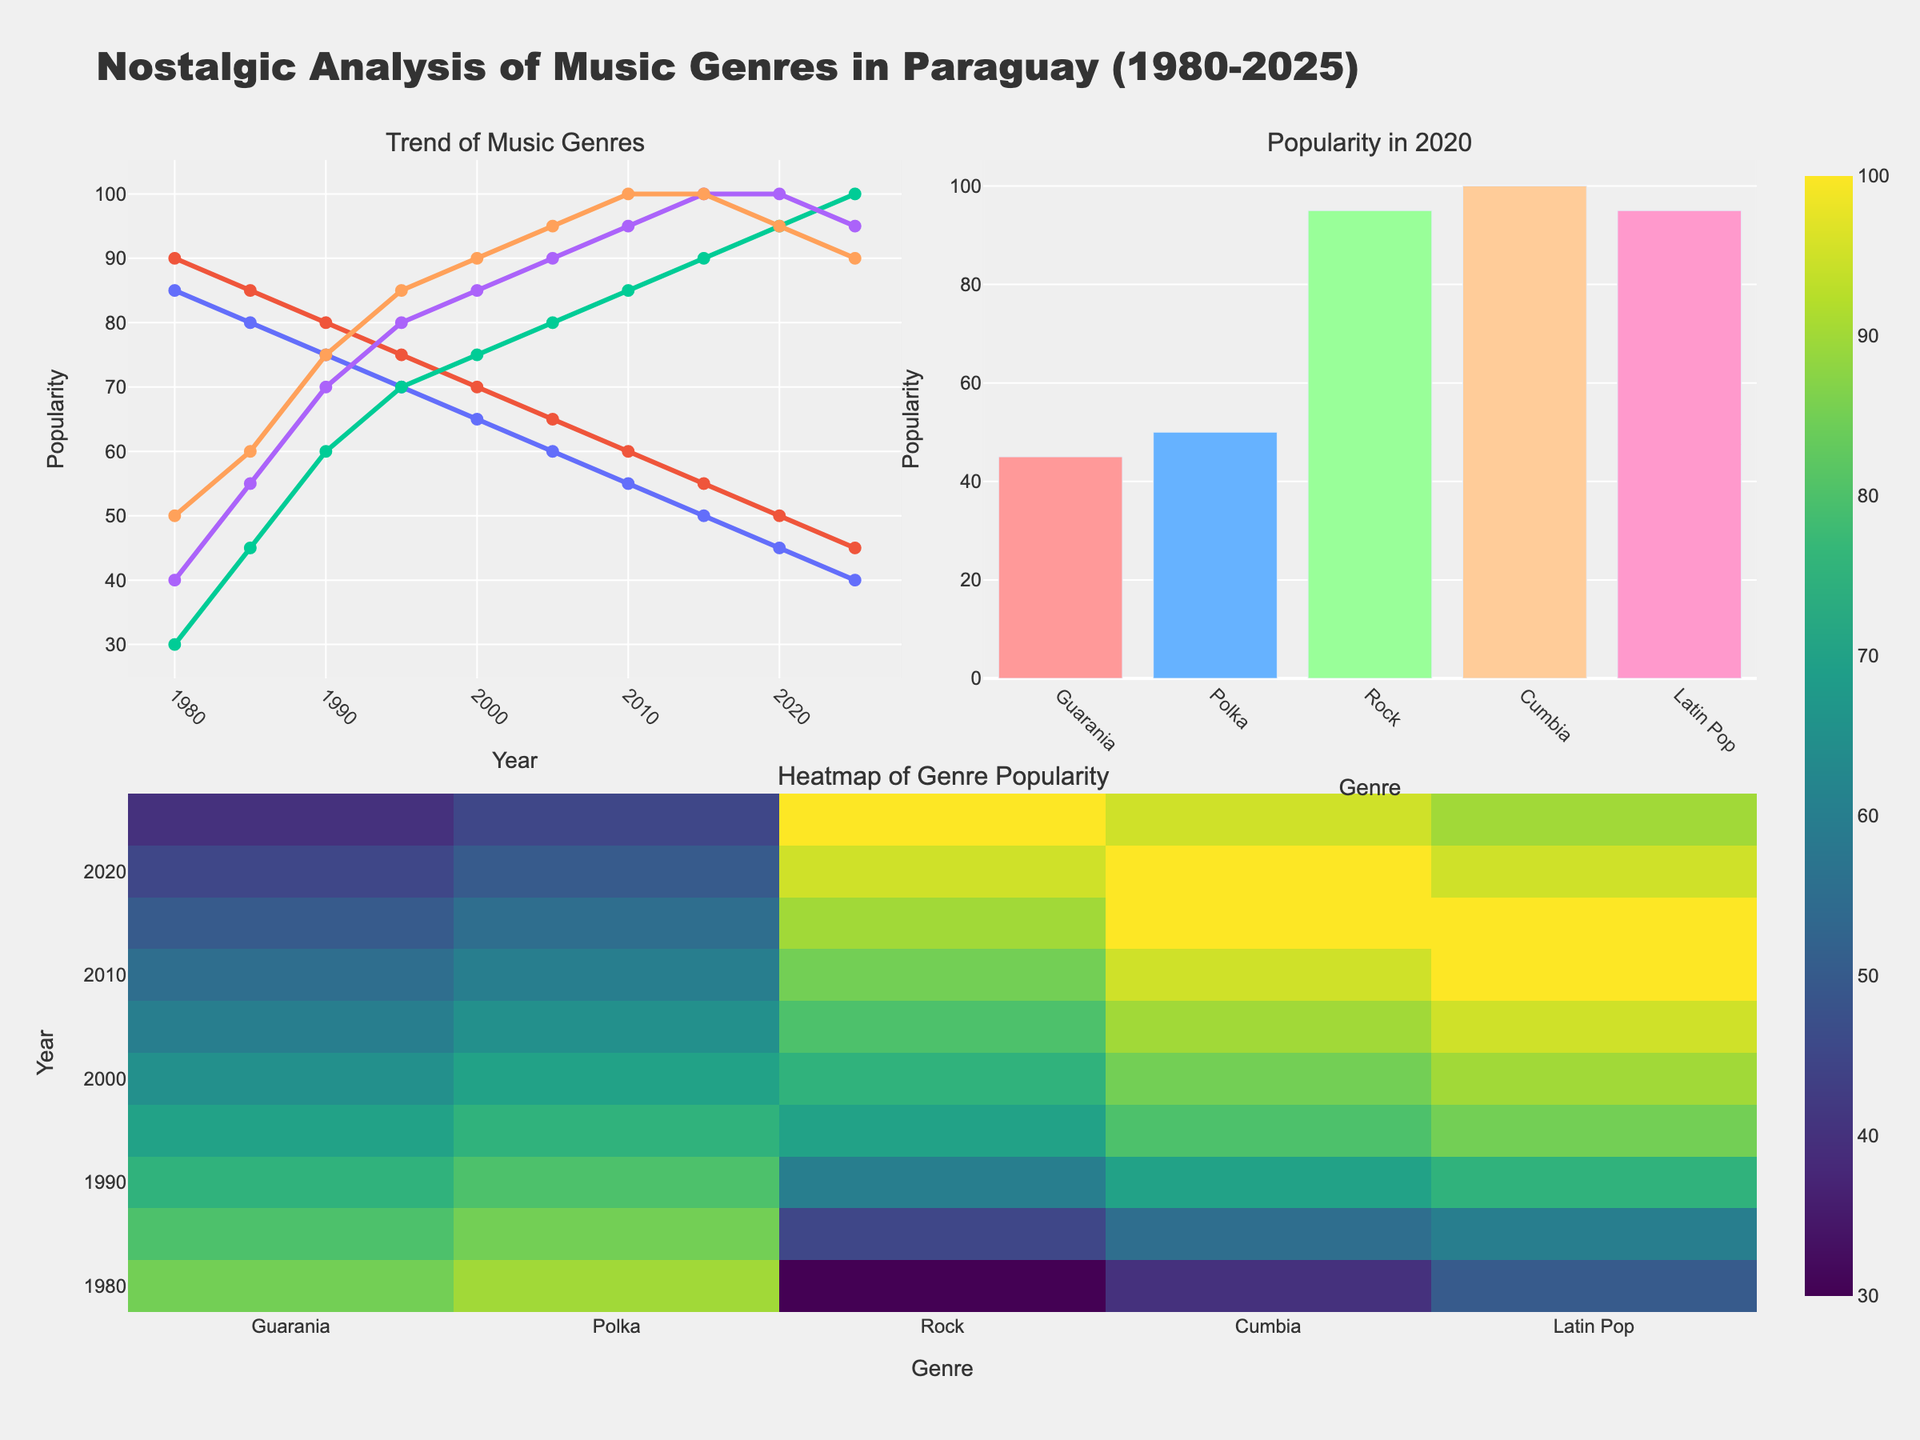what is the title of the figure? The title is written at the top of the figure in larger, bold font.
Answer: Nostalgic Analysis of Music Genres in Paraguay (1980-2025) which genre had the highest popularity in 2020 as per the bar chart? The bar chart shows different genres and their popularity values in 2020. The highest bar signifies the most popular genre.
Answer: Rock which genres show a continuous increase in popularity from 1980 to 2025 in the line plot? By observing the line plot, we can see the trends for each genre by following the path of each line from 1980 to 2025. The lines for Rock, Cumbia, and Latin Pop show a continuous increase.
Answer: Rock, Cumbia, Latin Pop what is the popularity difference between Guarania and Polka in 1990 according to the line plot? Locate the points for both Guarania and Polka in 1990 on the line plot and subtract their values. Guarania is at 75 and Polka is at 80, so the difference is 80 - 75.
Answer: 5 what pattern is depicted by the heatmap for Rock from 1980 to 2025? In the heatmap, we look at the cells corresponding to the 'Rock' column from 1980 to 2025. The colors become more intense over time, indicating an increase in popularity.
Answer: Increasing trend which year had the highest genre diversity in terms of popularity levels? Diversity in popularity can be inferred from the line plot. We look for the year when the popularity values of the different genres are most distinct from each other. The year 1980 shows the widest range of values, from 30 to 90.
Answer: 1980 is the popularity trend of Cumbia always increasing in the line plot? By checking Cumbia in the line plot from 1980 to 2025, we observe whether its value keeps rising or not. Yes, its trend is always ascending.
Answer: Yes what is the average popularity of Latin Pop from 1980 to 2025? Sum the popularity values of Latin Pop for all the years and divide by the number of years: (50+60+75+85+90+95+100+100+95+90)/10 = 84.
Answer: 84 which genre had the lowest minimum popularity according to the heatmap? In the heatmap, the genre with the overall lightest color represents the lowest minimum popularity. Guarania shows the lightest color at 40 in 2025.
Answer: Guarania how did Guarania's popularity change from 1980 to 2025? Examine the line plot for Guarania. It starts at 85 in 1980 and decreases gradually to 40 by 2025.
Answer: Decreasing 